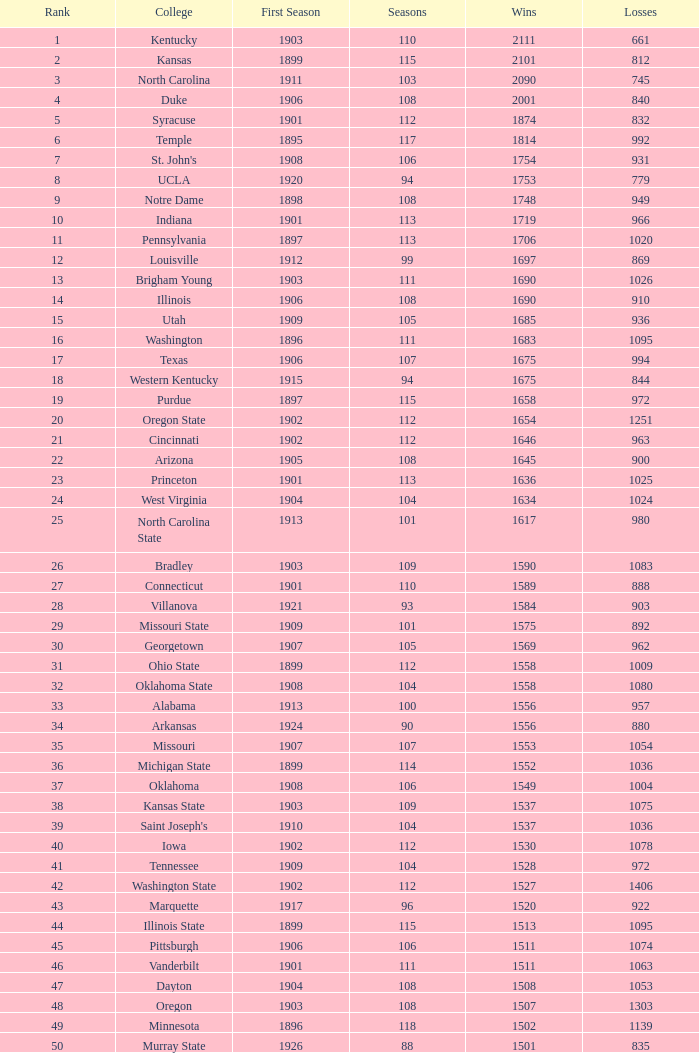How many victories did washington state college achieve with over 980 defeats, an initial season prior to 1906, and a ranking above 42? 0.0. 